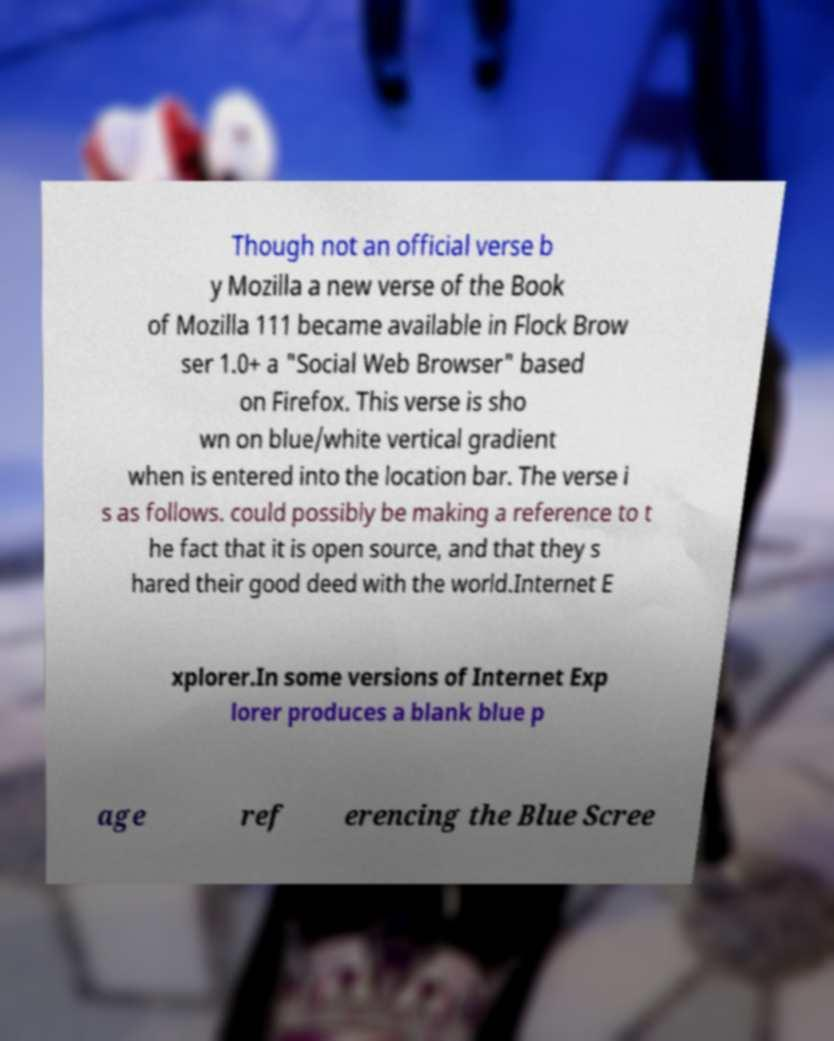Please identify and transcribe the text found in this image. Though not an official verse b y Mozilla a new verse of the Book of Mozilla 111 became available in Flock Brow ser 1.0+ a "Social Web Browser" based on Firefox. This verse is sho wn on blue/white vertical gradient when is entered into the location bar. The verse i s as follows. could possibly be making a reference to t he fact that it is open source, and that they s hared their good deed with the world.Internet E xplorer.In some versions of Internet Exp lorer produces a blank blue p age ref erencing the Blue Scree 